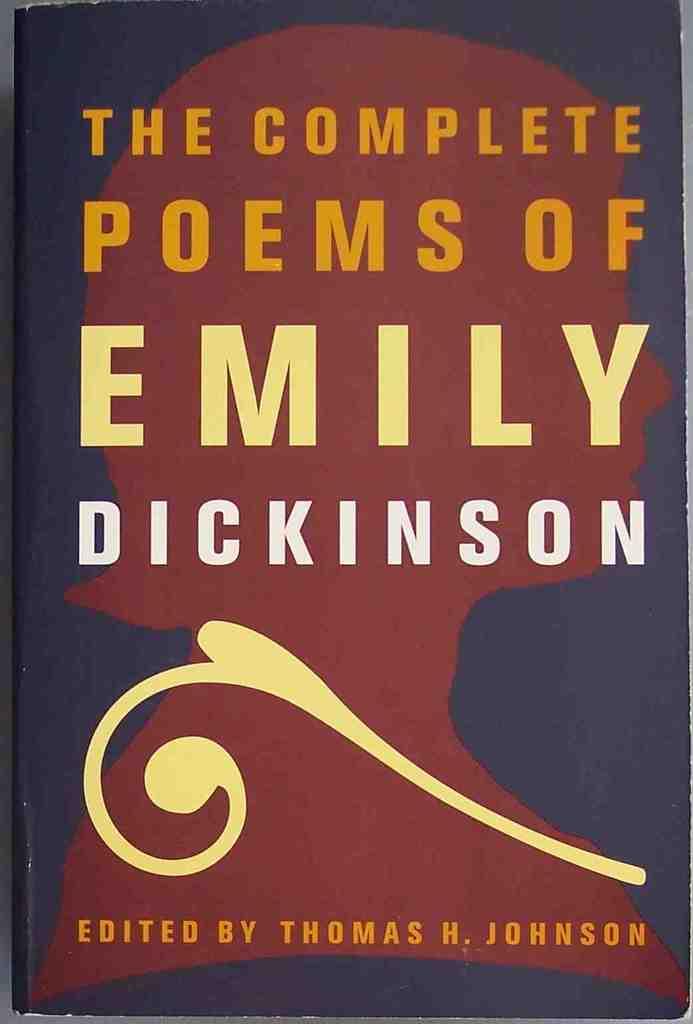Who's poems are in this book?
Give a very brief answer. Emily dickinson. Who edited this?
Provide a short and direct response. Thomas h. johnson. 